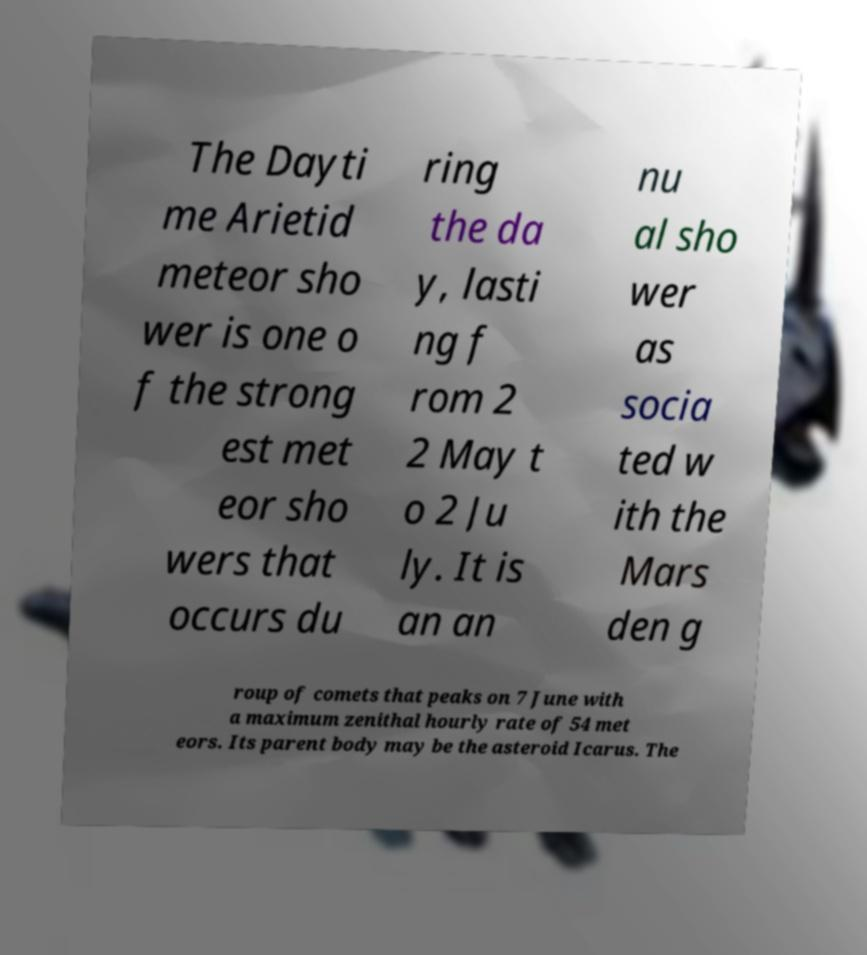Please read and relay the text visible in this image. What does it say? The Dayti me Arietid meteor sho wer is one o f the strong est met eor sho wers that occurs du ring the da y, lasti ng f rom 2 2 May t o 2 Ju ly. It is an an nu al sho wer as socia ted w ith the Mars den g roup of comets that peaks on 7 June with a maximum zenithal hourly rate of 54 met eors. Its parent body may be the asteroid Icarus. The 